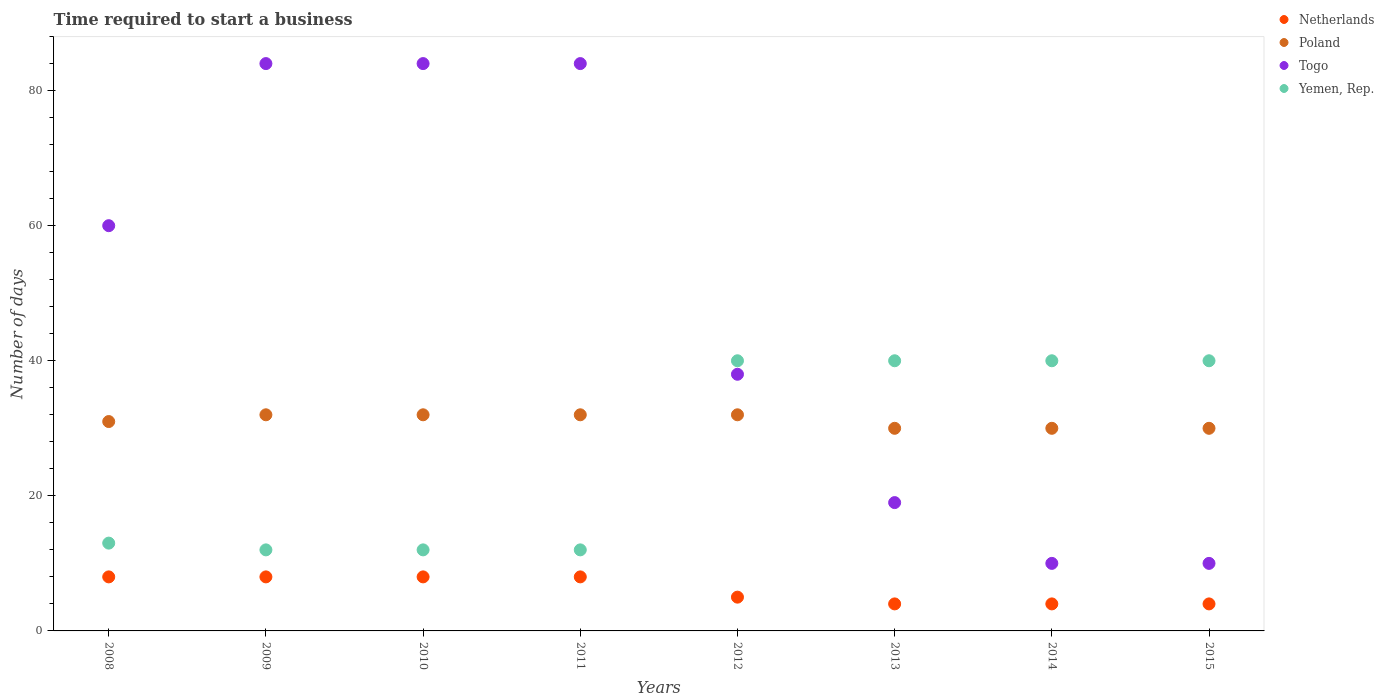What is the number of days required to start a business in Yemen, Rep. in 2009?
Give a very brief answer. 12. Across all years, what is the maximum number of days required to start a business in Yemen, Rep.?
Make the answer very short. 40. Across all years, what is the minimum number of days required to start a business in Poland?
Provide a succinct answer. 30. In which year was the number of days required to start a business in Togo maximum?
Make the answer very short. 2009. In which year was the number of days required to start a business in Togo minimum?
Offer a very short reply. 2014. What is the total number of days required to start a business in Poland in the graph?
Your response must be concise. 249. What is the difference between the number of days required to start a business in Poland in 2010 and that in 2013?
Your answer should be very brief. 2. What is the difference between the number of days required to start a business in Poland in 2009 and the number of days required to start a business in Togo in 2010?
Make the answer very short. -52. What is the average number of days required to start a business in Netherlands per year?
Provide a succinct answer. 6.12. In the year 2010, what is the difference between the number of days required to start a business in Yemen, Rep. and number of days required to start a business in Togo?
Provide a short and direct response. -72. In how many years, is the number of days required to start a business in Yemen, Rep. greater than 64 days?
Give a very brief answer. 0. What is the ratio of the number of days required to start a business in Poland in 2010 to that in 2013?
Your answer should be compact. 1.07. Is the number of days required to start a business in Poland in 2013 less than that in 2014?
Provide a short and direct response. No. What is the difference between the highest and the lowest number of days required to start a business in Togo?
Keep it short and to the point. 74. Is it the case that in every year, the sum of the number of days required to start a business in Poland and number of days required to start a business in Yemen, Rep.  is greater than the number of days required to start a business in Togo?
Your response must be concise. No. Does the number of days required to start a business in Yemen, Rep. monotonically increase over the years?
Your answer should be very brief. No. How many years are there in the graph?
Ensure brevity in your answer.  8. Are the values on the major ticks of Y-axis written in scientific E-notation?
Offer a terse response. No. Does the graph contain any zero values?
Ensure brevity in your answer.  No. Where does the legend appear in the graph?
Your response must be concise. Top right. How are the legend labels stacked?
Give a very brief answer. Vertical. What is the title of the graph?
Offer a very short reply. Time required to start a business. Does "Palau" appear as one of the legend labels in the graph?
Your answer should be very brief. No. What is the label or title of the Y-axis?
Provide a short and direct response. Number of days. What is the Number of days of Poland in 2008?
Your response must be concise. 31. What is the Number of days in Yemen, Rep. in 2008?
Provide a succinct answer. 13. What is the Number of days of Togo in 2009?
Ensure brevity in your answer.  84. What is the Number of days of Yemen, Rep. in 2009?
Give a very brief answer. 12. What is the Number of days in Netherlands in 2010?
Your answer should be very brief. 8. What is the Number of days in Yemen, Rep. in 2010?
Provide a short and direct response. 12. What is the Number of days in Poland in 2011?
Keep it short and to the point. 32. What is the Number of days in Togo in 2011?
Ensure brevity in your answer.  84. What is the Number of days of Yemen, Rep. in 2011?
Your answer should be compact. 12. What is the Number of days in Netherlands in 2012?
Ensure brevity in your answer.  5. What is the Number of days of Togo in 2012?
Give a very brief answer. 38. What is the Number of days of Yemen, Rep. in 2012?
Give a very brief answer. 40. What is the Number of days of Netherlands in 2013?
Your response must be concise. 4. What is the Number of days of Poland in 2013?
Your answer should be very brief. 30. What is the Number of days in Togo in 2013?
Provide a succinct answer. 19. What is the Number of days in Yemen, Rep. in 2013?
Your response must be concise. 40. What is the Number of days in Netherlands in 2014?
Offer a terse response. 4. What is the Number of days of Togo in 2014?
Ensure brevity in your answer.  10. What is the Number of days in Yemen, Rep. in 2014?
Give a very brief answer. 40. What is the Number of days of Netherlands in 2015?
Provide a succinct answer. 4. What is the Number of days in Poland in 2015?
Ensure brevity in your answer.  30. What is the Number of days of Togo in 2015?
Offer a terse response. 10. What is the Number of days of Yemen, Rep. in 2015?
Ensure brevity in your answer.  40. Across all years, what is the maximum Number of days in Netherlands?
Make the answer very short. 8. Across all years, what is the maximum Number of days of Togo?
Keep it short and to the point. 84. Across all years, what is the minimum Number of days in Poland?
Your answer should be very brief. 30. What is the total Number of days in Netherlands in the graph?
Provide a short and direct response. 49. What is the total Number of days in Poland in the graph?
Your answer should be compact. 249. What is the total Number of days in Togo in the graph?
Offer a terse response. 389. What is the total Number of days in Yemen, Rep. in the graph?
Provide a succinct answer. 209. What is the difference between the Number of days of Poland in 2008 and that in 2009?
Give a very brief answer. -1. What is the difference between the Number of days in Netherlands in 2008 and that in 2010?
Offer a very short reply. 0. What is the difference between the Number of days of Togo in 2008 and that in 2010?
Keep it short and to the point. -24. What is the difference between the Number of days of Togo in 2008 and that in 2011?
Offer a terse response. -24. What is the difference between the Number of days of Netherlands in 2008 and that in 2012?
Offer a terse response. 3. What is the difference between the Number of days of Netherlands in 2008 and that in 2013?
Your answer should be compact. 4. What is the difference between the Number of days in Yemen, Rep. in 2008 and that in 2013?
Provide a short and direct response. -27. What is the difference between the Number of days of Poland in 2008 and that in 2014?
Make the answer very short. 1. What is the difference between the Number of days in Togo in 2008 and that in 2014?
Give a very brief answer. 50. What is the difference between the Number of days of Netherlands in 2008 and that in 2015?
Provide a short and direct response. 4. What is the difference between the Number of days in Togo in 2008 and that in 2015?
Give a very brief answer. 50. What is the difference between the Number of days of Yemen, Rep. in 2008 and that in 2015?
Keep it short and to the point. -27. What is the difference between the Number of days in Poland in 2009 and that in 2010?
Offer a very short reply. 0. What is the difference between the Number of days of Togo in 2009 and that in 2010?
Ensure brevity in your answer.  0. What is the difference between the Number of days in Yemen, Rep. in 2009 and that in 2010?
Make the answer very short. 0. What is the difference between the Number of days in Togo in 2009 and that in 2011?
Offer a terse response. 0. What is the difference between the Number of days in Yemen, Rep. in 2009 and that in 2011?
Give a very brief answer. 0. What is the difference between the Number of days in Togo in 2009 and that in 2012?
Keep it short and to the point. 46. What is the difference between the Number of days in Yemen, Rep. in 2009 and that in 2012?
Your answer should be very brief. -28. What is the difference between the Number of days of Netherlands in 2009 and that in 2013?
Provide a succinct answer. 4. What is the difference between the Number of days of Poland in 2009 and that in 2013?
Your answer should be very brief. 2. What is the difference between the Number of days in Togo in 2009 and that in 2013?
Ensure brevity in your answer.  65. What is the difference between the Number of days in Yemen, Rep. in 2009 and that in 2013?
Ensure brevity in your answer.  -28. What is the difference between the Number of days in Netherlands in 2009 and that in 2014?
Give a very brief answer. 4. What is the difference between the Number of days in Yemen, Rep. in 2009 and that in 2014?
Offer a terse response. -28. What is the difference between the Number of days in Yemen, Rep. in 2009 and that in 2015?
Offer a terse response. -28. What is the difference between the Number of days of Netherlands in 2010 and that in 2011?
Offer a very short reply. 0. What is the difference between the Number of days in Poland in 2010 and that in 2011?
Make the answer very short. 0. What is the difference between the Number of days of Togo in 2010 and that in 2011?
Make the answer very short. 0. What is the difference between the Number of days of Poland in 2010 and that in 2012?
Offer a very short reply. 0. What is the difference between the Number of days in Togo in 2010 and that in 2012?
Offer a very short reply. 46. What is the difference between the Number of days in Yemen, Rep. in 2010 and that in 2012?
Offer a very short reply. -28. What is the difference between the Number of days in Netherlands in 2010 and that in 2013?
Provide a succinct answer. 4. What is the difference between the Number of days of Poland in 2010 and that in 2013?
Make the answer very short. 2. What is the difference between the Number of days in Netherlands in 2010 and that in 2014?
Keep it short and to the point. 4. What is the difference between the Number of days of Poland in 2010 and that in 2014?
Offer a terse response. 2. What is the difference between the Number of days of Togo in 2010 and that in 2014?
Provide a short and direct response. 74. What is the difference between the Number of days in Yemen, Rep. in 2010 and that in 2014?
Ensure brevity in your answer.  -28. What is the difference between the Number of days of Yemen, Rep. in 2010 and that in 2015?
Offer a terse response. -28. What is the difference between the Number of days in Togo in 2011 and that in 2012?
Your response must be concise. 46. What is the difference between the Number of days of Yemen, Rep. in 2011 and that in 2012?
Your response must be concise. -28. What is the difference between the Number of days of Netherlands in 2011 and that in 2013?
Provide a succinct answer. 4. What is the difference between the Number of days of Netherlands in 2011 and that in 2014?
Give a very brief answer. 4. What is the difference between the Number of days of Togo in 2011 and that in 2014?
Keep it short and to the point. 74. What is the difference between the Number of days of Yemen, Rep. in 2011 and that in 2014?
Provide a short and direct response. -28. What is the difference between the Number of days of Netherlands in 2011 and that in 2015?
Your response must be concise. 4. What is the difference between the Number of days of Poland in 2011 and that in 2015?
Your response must be concise. 2. What is the difference between the Number of days in Yemen, Rep. in 2011 and that in 2015?
Ensure brevity in your answer.  -28. What is the difference between the Number of days in Togo in 2012 and that in 2013?
Your answer should be compact. 19. What is the difference between the Number of days of Yemen, Rep. in 2012 and that in 2013?
Make the answer very short. 0. What is the difference between the Number of days in Poland in 2012 and that in 2014?
Offer a terse response. 2. What is the difference between the Number of days in Togo in 2012 and that in 2014?
Offer a terse response. 28. What is the difference between the Number of days of Yemen, Rep. in 2012 and that in 2014?
Your answer should be compact. 0. What is the difference between the Number of days of Poland in 2012 and that in 2015?
Offer a terse response. 2. What is the difference between the Number of days in Yemen, Rep. in 2012 and that in 2015?
Offer a very short reply. 0. What is the difference between the Number of days of Yemen, Rep. in 2013 and that in 2014?
Your answer should be very brief. 0. What is the difference between the Number of days of Togo in 2013 and that in 2015?
Your answer should be compact. 9. What is the difference between the Number of days in Netherlands in 2014 and that in 2015?
Give a very brief answer. 0. What is the difference between the Number of days in Poland in 2014 and that in 2015?
Provide a short and direct response. 0. What is the difference between the Number of days of Netherlands in 2008 and the Number of days of Togo in 2009?
Provide a short and direct response. -76. What is the difference between the Number of days of Netherlands in 2008 and the Number of days of Yemen, Rep. in 2009?
Your answer should be compact. -4. What is the difference between the Number of days of Poland in 2008 and the Number of days of Togo in 2009?
Give a very brief answer. -53. What is the difference between the Number of days in Netherlands in 2008 and the Number of days in Poland in 2010?
Your answer should be very brief. -24. What is the difference between the Number of days of Netherlands in 2008 and the Number of days of Togo in 2010?
Your response must be concise. -76. What is the difference between the Number of days of Poland in 2008 and the Number of days of Togo in 2010?
Ensure brevity in your answer.  -53. What is the difference between the Number of days of Poland in 2008 and the Number of days of Yemen, Rep. in 2010?
Your response must be concise. 19. What is the difference between the Number of days in Togo in 2008 and the Number of days in Yemen, Rep. in 2010?
Provide a short and direct response. 48. What is the difference between the Number of days of Netherlands in 2008 and the Number of days of Poland in 2011?
Your answer should be compact. -24. What is the difference between the Number of days in Netherlands in 2008 and the Number of days in Togo in 2011?
Provide a short and direct response. -76. What is the difference between the Number of days of Netherlands in 2008 and the Number of days of Yemen, Rep. in 2011?
Make the answer very short. -4. What is the difference between the Number of days of Poland in 2008 and the Number of days of Togo in 2011?
Your answer should be very brief. -53. What is the difference between the Number of days in Poland in 2008 and the Number of days in Yemen, Rep. in 2011?
Ensure brevity in your answer.  19. What is the difference between the Number of days in Netherlands in 2008 and the Number of days in Poland in 2012?
Your answer should be very brief. -24. What is the difference between the Number of days in Netherlands in 2008 and the Number of days in Yemen, Rep. in 2012?
Provide a short and direct response. -32. What is the difference between the Number of days of Poland in 2008 and the Number of days of Yemen, Rep. in 2012?
Offer a terse response. -9. What is the difference between the Number of days in Netherlands in 2008 and the Number of days in Poland in 2013?
Keep it short and to the point. -22. What is the difference between the Number of days of Netherlands in 2008 and the Number of days of Togo in 2013?
Give a very brief answer. -11. What is the difference between the Number of days of Netherlands in 2008 and the Number of days of Yemen, Rep. in 2013?
Give a very brief answer. -32. What is the difference between the Number of days of Poland in 2008 and the Number of days of Togo in 2013?
Keep it short and to the point. 12. What is the difference between the Number of days in Poland in 2008 and the Number of days in Yemen, Rep. in 2013?
Give a very brief answer. -9. What is the difference between the Number of days in Netherlands in 2008 and the Number of days in Togo in 2014?
Give a very brief answer. -2. What is the difference between the Number of days in Netherlands in 2008 and the Number of days in Yemen, Rep. in 2014?
Offer a terse response. -32. What is the difference between the Number of days in Poland in 2008 and the Number of days in Togo in 2014?
Your answer should be very brief. 21. What is the difference between the Number of days in Poland in 2008 and the Number of days in Yemen, Rep. in 2014?
Your answer should be compact. -9. What is the difference between the Number of days of Togo in 2008 and the Number of days of Yemen, Rep. in 2014?
Ensure brevity in your answer.  20. What is the difference between the Number of days in Netherlands in 2008 and the Number of days in Poland in 2015?
Offer a very short reply. -22. What is the difference between the Number of days in Netherlands in 2008 and the Number of days in Togo in 2015?
Your answer should be compact. -2. What is the difference between the Number of days of Netherlands in 2008 and the Number of days of Yemen, Rep. in 2015?
Give a very brief answer. -32. What is the difference between the Number of days in Togo in 2008 and the Number of days in Yemen, Rep. in 2015?
Offer a terse response. 20. What is the difference between the Number of days in Netherlands in 2009 and the Number of days in Poland in 2010?
Ensure brevity in your answer.  -24. What is the difference between the Number of days in Netherlands in 2009 and the Number of days in Togo in 2010?
Keep it short and to the point. -76. What is the difference between the Number of days in Poland in 2009 and the Number of days in Togo in 2010?
Offer a very short reply. -52. What is the difference between the Number of days of Poland in 2009 and the Number of days of Yemen, Rep. in 2010?
Your response must be concise. 20. What is the difference between the Number of days in Togo in 2009 and the Number of days in Yemen, Rep. in 2010?
Provide a succinct answer. 72. What is the difference between the Number of days in Netherlands in 2009 and the Number of days in Togo in 2011?
Provide a succinct answer. -76. What is the difference between the Number of days of Poland in 2009 and the Number of days of Togo in 2011?
Make the answer very short. -52. What is the difference between the Number of days in Togo in 2009 and the Number of days in Yemen, Rep. in 2011?
Your response must be concise. 72. What is the difference between the Number of days in Netherlands in 2009 and the Number of days in Togo in 2012?
Your answer should be compact. -30. What is the difference between the Number of days of Netherlands in 2009 and the Number of days of Yemen, Rep. in 2012?
Give a very brief answer. -32. What is the difference between the Number of days in Poland in 2009 and the Number of days in Togo in 2012?
Offer a very short reply. -6. What is the difference between the Number of days of Poland in 2009 and the Number of days of Yemen, Rep. in 2012?
Provide a succinct answer. -8. What is the difference between the Number of days in Togo in 2009 and the Number of days in Yemen, Rep. in 2012?
Your answer should be compact. 44. What is the difference between the Number of days in Netherlands in 2009 and the Number of days in Poland in 2013?
Provide a short and direct response. -22. What is the difference between the Number of days in Netherlands in 2009 and the Number of days in Togo in 2013?
Ensure brevity in your answer.  -11. What is the difference between the Number of days of Netherlands in 2009 and the Number of days of Yemen, Rep. in 2013?
Offer a terse response. -32. What is the difference between the Number of days in Poland in 2009 and the Number of days in Togo in 2013?
Ensure brevity in your answer.  13. What is the difference between the Number of days of Netherlands in 2009 and the Number of days of Poland in 2014?
Your answer should be compact. -22. What is the difference between the Number of days of Netherlands in 2009 and the Number of days of Togo in 2014?
Your response must be concise. -2. What is the difference between the Number of days of Netherlands in 2009 and the Number of days of Yemen, Rep. in 2014?
Make the answer very short. -32. What is the difference between the Number of days of Poland in 2009 and the Number of days of Yemen, Rep. in 2014?
Your answer should be compact. -8. What is the difference between the Number of days of Togo in 2009 and the Number of days of Yemen, Rep. in 2014?
Your response must be concise. 44. What is the difference between the Number of days of Netherlands in 2009 and the Number of days of Poland in 2015?
Provide a short and direct response. -22. What is the difference between the Number of days in Netherlands in 2009 and the Number of days in Togo in 2015?
Your answer should be compact. -2. What is the difference between the Number of days of Netherlands in 2009 and the Number of days of Yemen, Rep. in 2015?
Offer a very short reply. -32. What is the difference between the Number of days in Poland in 2009 and the Number of days in Togo in 2015?
Your answer should be compact. 22. What is the difference between the Number of days in Poland in 2009 and the Number of days in Yemen, Rep. in 2015?
Your response must be concise. -8. What is the difference between the Number of days of Togo in 2009 and the Number of days of Yemen, Rep. in 2015?
Provide a succinct answer. 44. What is the difference between the Number of days of Netherlands in 2010 and the Number of days of Togo in 2011?
Your answer should be very brief. -76. What is the difference between the Number of days in Netherlands in 2010 and the Number of days in Yemen, Rep. in 2011?
Your answer should be compact. -4. What is the difference between the Number of days of Poland in 2010 and the Number of days of Togo in 2011?
Keep it short and to the point. -52. What is the difference between the Number of days in Netherlands in 2010 and the Number of days in Poland in 2012?
Give a very brief answer. -24. What is the difference between the Number of days of Netherlands in 2010 and the Number of days of Yemen, Rep. in 2012?
Provide a short and direct response. -32. What is the difference between the Number of days of Netherlands in 2010 and the Number of days of Yemen, Rep. in 2013?
Your answer should be compact. -32. What is the difference between the Number of days of Poland in 2010 and the Number of days of Togo in 2013?
Give a very brief answer. 13. What is the difference between the Number of days of Poland in 2010 and the Number of days of Yemen, Rep. in 2013?
Provide a short and direct response. -8. What is the difference between the Number of days in Togo in 2010 and the Number of days in Yemen, Rep. in 2013?
Provide a succinct answer. 44. What is the difference between the Number of days in Netherlands in 2010 and the Number of days in Poland in 2014?
Give a very brief answer. -22. What is the difference between the Number of days of Netherlands in 2010 and the Number of days of Togo in 2014?
Offer a terse response. -2. What is the difference between the Number of days in Netherlands in 2010 and the Number of days in Yemen, Rep. in 2014?
Give a very brief answer. -32. What is the difference between the Number of days of Poland in 2010 and the Number of days of Yemen, Rep. in 2014?
Your answer should be very brief. -8. What is the difference between the Number of days in Togo in 2010 and the Number of days in Yemen, Rep. in 2014?
Offer a terse response. 44. What is the difference between the Number of days of Netherlands in 2010 and the Number of days of Poland in 2015?
Provide a short and direct response. -22. What is the difference between the Number of days of Netherlands in 2010 and the Number of days of Togo in 2015?
Make the answer very short. -2. What is the difference between the Number of days of Netherlands in 2010 and the Number of days of Yemen, Rep. in 2015?
Make the answer very short. -32. What is the difference between the Number of days of Poland in 2010 and the Number of days of Togo in 2015?
Keep it short and to the point. 22. What is the difference between the Number of days of Togo in 2010 and the Number of days of Yemen, Rep. in 2015?
Your answer should be very brief. 44. What is the difference between the Number of days in Netherlands in 2011 and the Number of days in Poland in 2012?
Make the answer very short. -24. What is the difference between the Number of days in Netherlands in 2011 and the Number of days in Togo in 2012?
Offer a very short reply. -30. What is the difference between the Number of days in Netherlands in 2011 and the Number of days in Yemen, Rep. in 2012?
Your response must be concise. -32. What is the difference between the Number of days of Poland in 2011 and the Number of days of Yemen, Rep. in 2012?
Provide a succinct answer. -8. What is the difference between the Number of days in Togo in 2011 and the Number of days in Yemen, Rep. in 2012?
Offer a very short reply. 44. What is the difference between the Number of days in Netherlands in 2011 and the Number of days in Poland in 2013?
Your response must be concise. -22. What is the difference between the Number of days of Netherlands in 2011 and the Number of days of Yemen, Rep. in 2013?
Offer a terse response. -32. What is the difference between the Number of days of Poland in 2011 and the Number of days of Togo in 2013?
Provide a succinct answer. 13. What is the difference between the Number of days in Netherlands in 2011 and the Number of days in Poland in 2014?
Offer a terse response. -22. What is the difference between the Number of days of Netherlands in 2011 and the Number of days of Yemen, Rep. in 2014?
Ensure brevity in your answer.  -32. What is the difference between the Number of days in Poland in 2011 and the Number of days in Togo in 2014?
Your response must be concise. 22. What is the difference between the Number of days of Poland in 2011 and the Number of days of Yemen, Rep. in 2014?
Offer a terse response. -8. What is the difference between the Number of days in Togo in 2011 and the Number of days in Yemen, Rep. in 2014?
Your answer should be very brief. 44. What is the difference between the Number of days of Netherlands in 2011 and the Number of days of Togo in 2015?
Your answer should be very brief. -2. What is the difference between the Number of days in Netherlands in 2011 and the Number of days in Yemen, Rep. in 2015?
Make the answer very short. -32. What is the difference between the Number of days in Poland in 2011 and the Number of days in Togo in 2015?
Your answer should be compact. 22. What is the difference between the Number of days in Poland in 2011 and the Number of days in Yemen, Rep. in 2015?
Ensure brevity in your answer.  -8. What is the difference between the Number of days in Netherlands in 2012 and the Number of days in Poland in 2013?
Make the answer very short. -25. What is the difference between the Number of days in Netherlands in 2012 and the Number of days in Yemen, Rep. in 2013?
Make the answer very short. -35. What is the difference between the Number of days in Poland in 2012 and the Number of days in Yemen, Rep. in 2013?
Make the answer very short. -8. What is the difference between the Number of days in Netherlands in 2012 and the Number of days in Poland in 2014?
Your answer should be very brief. -25. What is the difference between the Number of days of Netherlands in 2012 and the Number of days of Togo in 2014?
Provide a succinct answer. -5. What is the difference between the Number of days in Netherlands in 2012 and the Number of days in Yemen, Rep. in 2014?
Provide a short and direct response. -35. What is the difference between the Number of days in Poland in 2012 and the Number of days in Togo in 2014?
Give a very brief answer. 22. What is the difference between the Number of days in Netherlands in 2012 and the Number of days in Poland in 2015?
Keep it short and to the point. -25. What is the difference between the Number of days of Netherlands in 2012 and the Number of days of Yemen, Rep. in 2015?
Ensure brevity in your answer.  -35. What is the difference between the Number of days in Poland in 2012 and the Number of days in Togo in 2015?
Your answer should be compact. 22. What is the difference between the Number of days in Poland in 2012 and the Number of days in Yemen, Rep. in 2015?
Provide a short and direct response. -8. What is the difference between the Number of days in Netherlands in 2013 and the Number of days in Poland in 2014?
Give a very brief answer. -26. What is the difference between the Number of days of Netherlands in 2013 and the Number of days of Yemen, Rep. in 2014?
Your response must be concise. -36. What is the difference between the Number of days in Poland in 2013 and the Number of days in Togo in 2014?
Keep it short and to the point. 20. What is the difference between the Number of days of Togo in 2013 and the Number of days of Yemen, Rep. in 2014?
Your answer should be compact. -21. What is the difference between the Number of days in Netherlands in 2013 and the Number of days in Poland in 2015?
Your answer should be compact. -26. What is the difference between the Number of days of Netherlands in 2013 and the Number of days of Togo in 2015?
Make the answer very short. -6. What is the difference between the Number of days of Netherlands in 2013 and the Number of days of Yemen, Rep. in 2015?
Make the answer very short. -36. What is the difference between the Number of days of Poland in 2013 and the Number of days of Togo in 2015?
Provide a succinct answer. 20. What is the difference between the Number of days of Togo in 2013 and the Number of days of Yemen, Rep. in 2015?
Keep it short and to the point. -21. What is the difference between the Number of days of Netherlands in 2014 and the Number of days of Poland in 2015?
Your answer should be very brief. -26. What is the difference between the Number of days in Netherlands in 2014 and the Number of days in Yemen, Rep. in 2015?
Make the answer very short. -36. What is the difference between the Number of days in Poland in 2014 and the Number of days in Yemen, Rep. in 2015?
Your response must be concise. -10. What is the difference between the Number of days in Togo in 2014 and the Number of days in Yemen, Rep. in 2015?
Keep it short and to the point. -30. What is the average Number of days of Netherlands per year?
Offer a very short reply. 6.12. What is the average Number of days of Poland per year?
Offer a very short reply. 31.12. What is the average Number of days of Togo per year?
Your answer should be very brief. 48.62. What is the average Number of days in Yemen, Rep. per year?
Give a very brief answer. 26.12. In the year 2008, what is the difference between the Number of days of Netherlands and Number of days of Poland?
Your response must be concise. -23. In the year 2008, what is the difference between the Number of days of Netherlands and Number of days of Togo?
Your response must be concise. -52. In the year 2008, what is the difference between the Number of days in Poland and Number of days in Togo?
Offer a very short reply. -29. In the year 2009, what is the difference between the Number of days in Netherlands and Number of days in Togo?
Keep it short and to the point. -76. In the year 2009, what is the difference between the Number of days of Netherlands and Number of days of Yemen, Rep.?
Your answer should be compact. -4. In the year 2009, what is the difference between the Number of days of Poland and Number of days of Togo?
Ensure brevity in your answer.  -52. In the year 2009, what is the difference between the Number of days of Togo and Number of days of Yemen, Rep.?
Provide a short and direct response. 72. In the year 2010, what is the difference between the Number of days of Netherlands and Number of days of Poland?
Offer a terse response. -24. In the year 2010, what is the difference between the Number of days in Netherlands and Number of days in Togo?
Your response must be concise. -76. In the year 2010, what is the difference between the Number of days in Poland and Number of days in Togo?
Your answer should be compact. -52. In the year 2011, what is the difference between the Number of days of Netherlands and Number of days of Togo?
Offer a very short reply. -76. In the year 2011, what is the difference between the Number of days of Poland and Number of days of Togo?
Your answer should be very brief. -52. In the year 2011, what is the difference between the Number of days of Poland and Number of days of Yemen, Rep.?
Your answer should be very brief. 20. In the year 2011, what is the difference between the Number of days in Togo and Number of days in Yemen, Rep.?
Provide a short and direct response. 72. In the year 2012, what is the difference between the Number of days of Netherlands and Number of days of Togo?
Ensure brevity in your answer.  -33. In the year 2012, what is the difference between the Number of days of Netherlands and Number of days of Yemen, Rep.?
Make the answer very short. -35. In the year 2012, what is the difference between the Number of days in Poland and Number of days in Togo?
Ensure brevity in your answer.  -6. In the year 2012, what is the difference between the Number of days in Poland and Number of days in Yemen, Rep.?
Provide a succinct answer. -8. In the year 2012, what is the difference between the Number of days of Togo and Number of days of Yemen, Rep.?
Make the answer very short. -2. In the year 2013, what is the difference between the Number of days of Netherlands and Number of days of Poland?
Make the answer very short. -26. In the year 2013, what is the difference between the Number of days in Netherlands and Number of days in Togo?
Your response must be concise. -15. In the year 2013, what is the difference between the Number of days in Netherlands and Number of days in Yemen, Rep.?
Keep it short and to the point. -36. In the year 2013, what is the difference between the Number of days of Poland and Number of days of Togo?
Offer a terse response. 11. In the year 2013, what is the difference between the Number of days in Togo and Number of days in Yemen, Rep.?
Offer a terse response. -21. In the year 2014, what is the difference between the Number of days of Netherlands and Number of days of Yemen, Rep.?
Provide a succinct answer. -36. In the year 2014, what is the difference between the Number of days of Poland and Number of days of Togo?
Keep it short and to the point. 20. In the year 2014, what is the difference between the Number of days in Poland and Number of days in Yemen, Rep.?
Keep it short and to the point. -10. In the year 2014, what is the difference between the Number of days in Togo and Number of days in Yemen, Rep.?
Offer a very short reply. -30. In the year 2015, what is the difference between the Number of days of Netherlands and Number of days of Poland?
Your response must be concise. -26. In the year 2015, what is the difference between the Number of days in Netherlands and Number of days in Togo?
Ensure brevity in your answer.  -6. In the year 2015, what is the difference between the Number of days of Netherlands and Number of days of Yemen, Rep.?
Give a very brief answer. -36. In the year 2015, what is the difference between the Number of days in Poland and Number of days in Yemen, Rep.?
Ensure brevity in your answer.  -10. In the year 2015, what is the difference between the Number of days in Togo and Number of days in Yemen, Rep.?
Your response must be concise. -30. What is the ratio of the Number of days in Netherlands in 2008 to that in 2009?
Offer a terse response. 1. What is the ratio of the Number of days of Poland in 2008 to that in 2009?
Keep it short and to the point. 0.97. What is the ratio of the Number of days of Togo in 2008 to that in 2009?
Offer a terse response. 0.71. What is the ratio of the Number of days of Poland in 2008 to that in 2010?
Offer a terse response. 0.97. What is the ratio of the Number of days in Netherlands in 2008 to that in 2011?
Your answer should be very brief. 1. What is the ratio of the Number of days of Poland in 2008 to that in 2011?
Provide a succinct answer. 0.97. What is the ratio of the Number of days of Togo in 2008 to that in 2011?
Make the answer very short. 0.71. What is the ratio of the Number of days in Yemen, Rep. in 2008 to that in 2011?
Give a very brief answer. 1.08. What is the ratio of the Number of days of Poland in 2008 to that in 2012?
Your answer should be compact. 0.97. What is the ratio of the Number of days in Togo in 2008 to that in 2012?
Your answer should be compact. 1.58. What is the ratio of the Number of days of Yemen, Rep. in 2008 to that in 2012?
Offer a terse response. 0.33. What is the ratio of the Number of days of Poland in 2008 to that in 2013?
Your response must be concise. 1.03. What is the ratio of the Number of days of Togo in 2008 to that in 2013?
Provide a short and direct response. 3.16. What is the ratio of the Number of days of Yemen, Rep. in 2008 to that in 2013?
Your answer should be compact. 0.33. What is the ratio of the Number of days in Poland in 2008 to that in 2014?
Your answer should be compact. 1.03. What is the ratio of the Number of days in Yemen, Rep. in 2008 to that in 2014?
Your answer should be compact. 0.33. What is the ratio of the Number of days of Poland in 2008 to that in 2015?
Provide a short and direct response. 1.03. What is the ratio of the Number of days in Togo in 2008 to that in 2015?
Give a very brief answer. 6. What is the ratio of the Number of days of Yemen, Rep. in 2008 to that in 2015?
Offer a very short reply. 0.33. What is the ratio of the Number of days of Netherlands in 2009 to that in 2010?
Your response must be concise. 1. What is the ratio of the Number of days in Togo in 2009 to that in 2010?
Offer a terse response. 1. What is the ratio of the Number of days of Togo in 2009 to that in 2012?
Provide a short and direct response. 2.21. What is the ratio of the Number of days in Yemen, Rep. in 2009 to that in 2012?
Your answer should be compact. 0.3. What is the ratio of the Number of days in Poland in 2009 to that in 2013?
Provide a short and direct response. 1.07. What is the ratio of the Number of days in Togo in 2009 to that in 2013?
Your response must be concise. 4.42. What is the ratio of the Number of days of Yemen, Rep. in 2009 to that in 2013?
Ensure brevity in your answer.  0.3. What is the ratio of the Number of days of Poland in 2009 to that in 2014?
Keep it short and to the point. 1.07. What is the ratio of the Number of days in Poland in 2009 to that in 2015?
Give a very brief answer. 1.07. What is the ratio of the Number of days of Netherlands in 2010 to that in 2011?
Ensure brevity in your answer.  1. What is the ratio of the Number of days in Togo in 2010 to that in 2011?
Ensure brevity in your answer.  1. What is the ratio of the Number of days of Poland in 2010 to that in 2012?
Your answer should be compact. 1. What is the ratio of the Number of days in Togo in 2010 to that in 2012?
Offer a very short reply. 2.21. What is the ratio of the Number of days of Yemen, Rep. in 2010 to that in 2012?
Offer a terse response. 0.3. What is the ratio of the Number of days in Poland in 2010 to that in 2013?
Your response must be concise. 1.07. What is the ratio of the Number of days in Togo in 2010 to that in 2013?
Ensure brevity in your answer.  4.42. What is the ratio of the Number of days in Yemen, Rep. in 2010 to that in 2013?
Ensure brevity in your answer.  0.3. What is the ratio of the Number of days of Poland in 2010 to that in 2014?
Provide a short and direct response. 1.07. What is the ratio of the Number of days in Netherlands in 2010 to that in 2015?
Make the answer very short. 2. What is the ratio of the Number of days in Poland in 2010 to that in 2015?
Keep it short and to the point. 1.07. What is the ratio of the Number of days in Togo in 2010 to that in 2015?
Give a very brief answer. 8.4. What is the ratio of the Number of days of Togo in 2011 to that in 2012?
Your answer should be compact. 2.21. What is the ratio of the Number of days in Yemen, Rep. in 2011 to that in 2012?
Ensure brevity in your answer.  0.3. What is the ratio of the Number of days of Netherlands in 2011 to that in 2013?
Your answer should be very brief. 2. What is the ratio of the Number of days of Poland in 2011 to that in 2013?
Ensure brevity in your answer.  1.07. What is the ratio of the Number of days of Togo in 2011 to that in 2013?
Your answer should be compact. 4.42. What is the ratio of the Number of days of Poland in 2011 to that in 2014?
Ensure brevity in your answer.  1.07. What is the ratio of the Number of days in Togo in 2011 to that in 2014?
Provide a short and direct response. 8.4. What is the ratio of the Number of days of Poland in 2011 to that in 2015?
Keep it short and to the point. 1.07. What is the ratio of the Number of days of Yemen, Rep. in 2011 to that in 2015?
Offer a terse response. 0.3. What is the ratio of the Number of days of Poland in 2012 to that in 2013?
Your response must be concise. 1.07. What is the ratio of the Number of days in Togo in 2012 to that in 2013?
Your response must be concise. 2. What is the ratio of the Number of days of Netherlands in 2012 to that in 2014?
Keep it short and to the point. 1.25. What is the ratio of the Number of days of Poland in 2012 to that in 2014?
Ensure brevity in your answer.  1.07. What is the ratio of the Number of days of Togo in 2012 to that in 2014?
Your answer should be very brief. 3.8. What is the ratio of the Number of days of Yemen, Rep. in 2012 to that in 2014?
Offer a terse response. 1. What is the ratio of the Number of days in Poland in 2012 to that in 2015?
Give a very brief answer. 1.07. What is the ratio of the Number of days in Netherlands in 2013 to that in 2014?
Provide a short and direct response. 1. What is the ratio of the Number of days of Yemen, Rep. in 2013 to that in 2014?
Keep it short and to the point. 1. What is the ratio of the Number of days of Netherlands in 2013 to that in 2015?
Offer a very short reply. 1. What is the ratio of the Number of days of Poland in 2013 to that in 2015?
Provide a succinct answer. 1. What is the ratio of the Number of days in Togo in 2014 to that in 2015?
Provide a short and direct response. 1. What is the difference between the highest and the second highest Number of days in Poland?
Give a very brief answer. 0. What is the difference between the highest and the lowest Number of days of Togo?
Provide a short and direct response. 74. What is the difference between the highest and the lowest Number of days in Yemen, Rep.?
Your response must be concise. 28. 